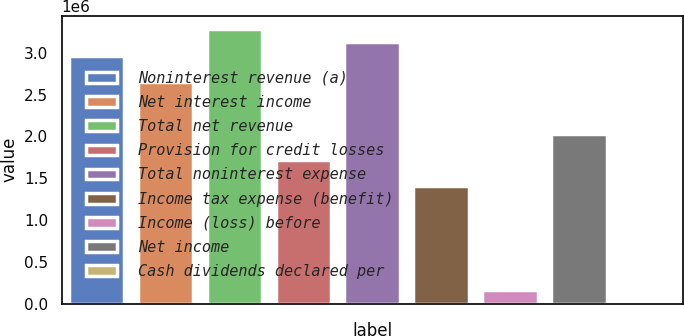Convert chart. <chart><loc_0><loc_0><loc_500><loc_500><bar_chart><fcel>Noninterest revenue (a)<fcel>Net interest income<fcel>Total net revenue<fcel>Provision for credit losses<fcel>Total noninterest expense<fcel>Income tax expense (benefit)<fcel>Income (loss) before<fcel>Net income<fcel>Cash dividends declared per<nl><fcel>2.96808e+06<fcel>2.65565e+06<fcel>3.28051e+06<fcel>1.71836e+06<fcel>3.12429e+06<fcel>1.40593e+06<fcel>156215<fcel>2.03079e+06<fcel>0.38<nl></chart> 